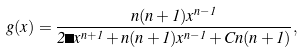Convert formula to latex. <formula><loc_0><loc_0><loc_500><loc_500>g ( x ) = \frac { n ( n + 1 ) x ^ { n - 1 } } { 2 \Lambda x ^ { n + 1 } + n ( n + 1 ) x ^ { n - 1 } + C n ( n + 1 ) } ,</formula> 